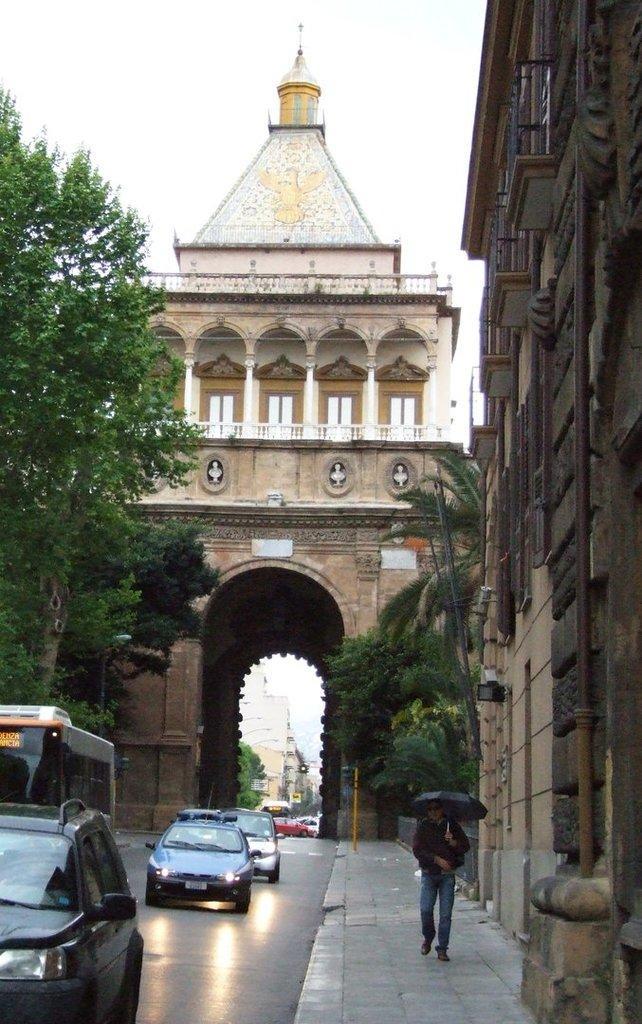Describe this image in one or two sentences. There is a man holding an umbrella and vehicles at the bottom side, there is the subway, an arch, vehicles, buildings, trees and the sky in the background. 